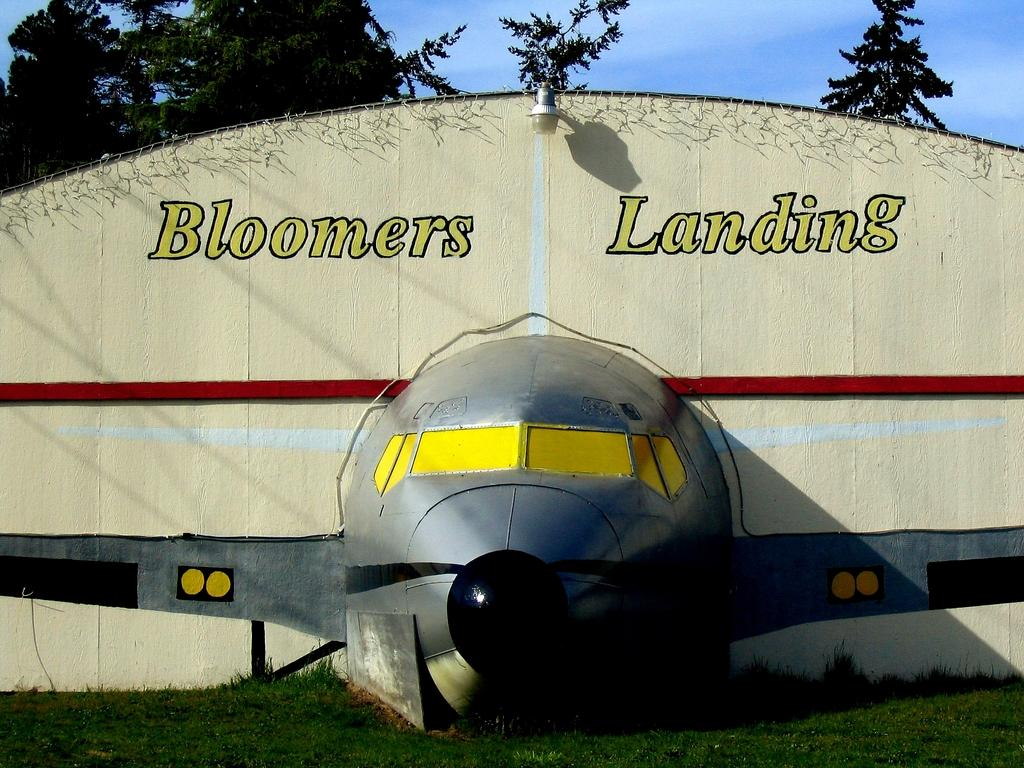<image>
Create a compact narrative representing the image presented. A building that says Bloomers Landing has a plane sticking out of it. 